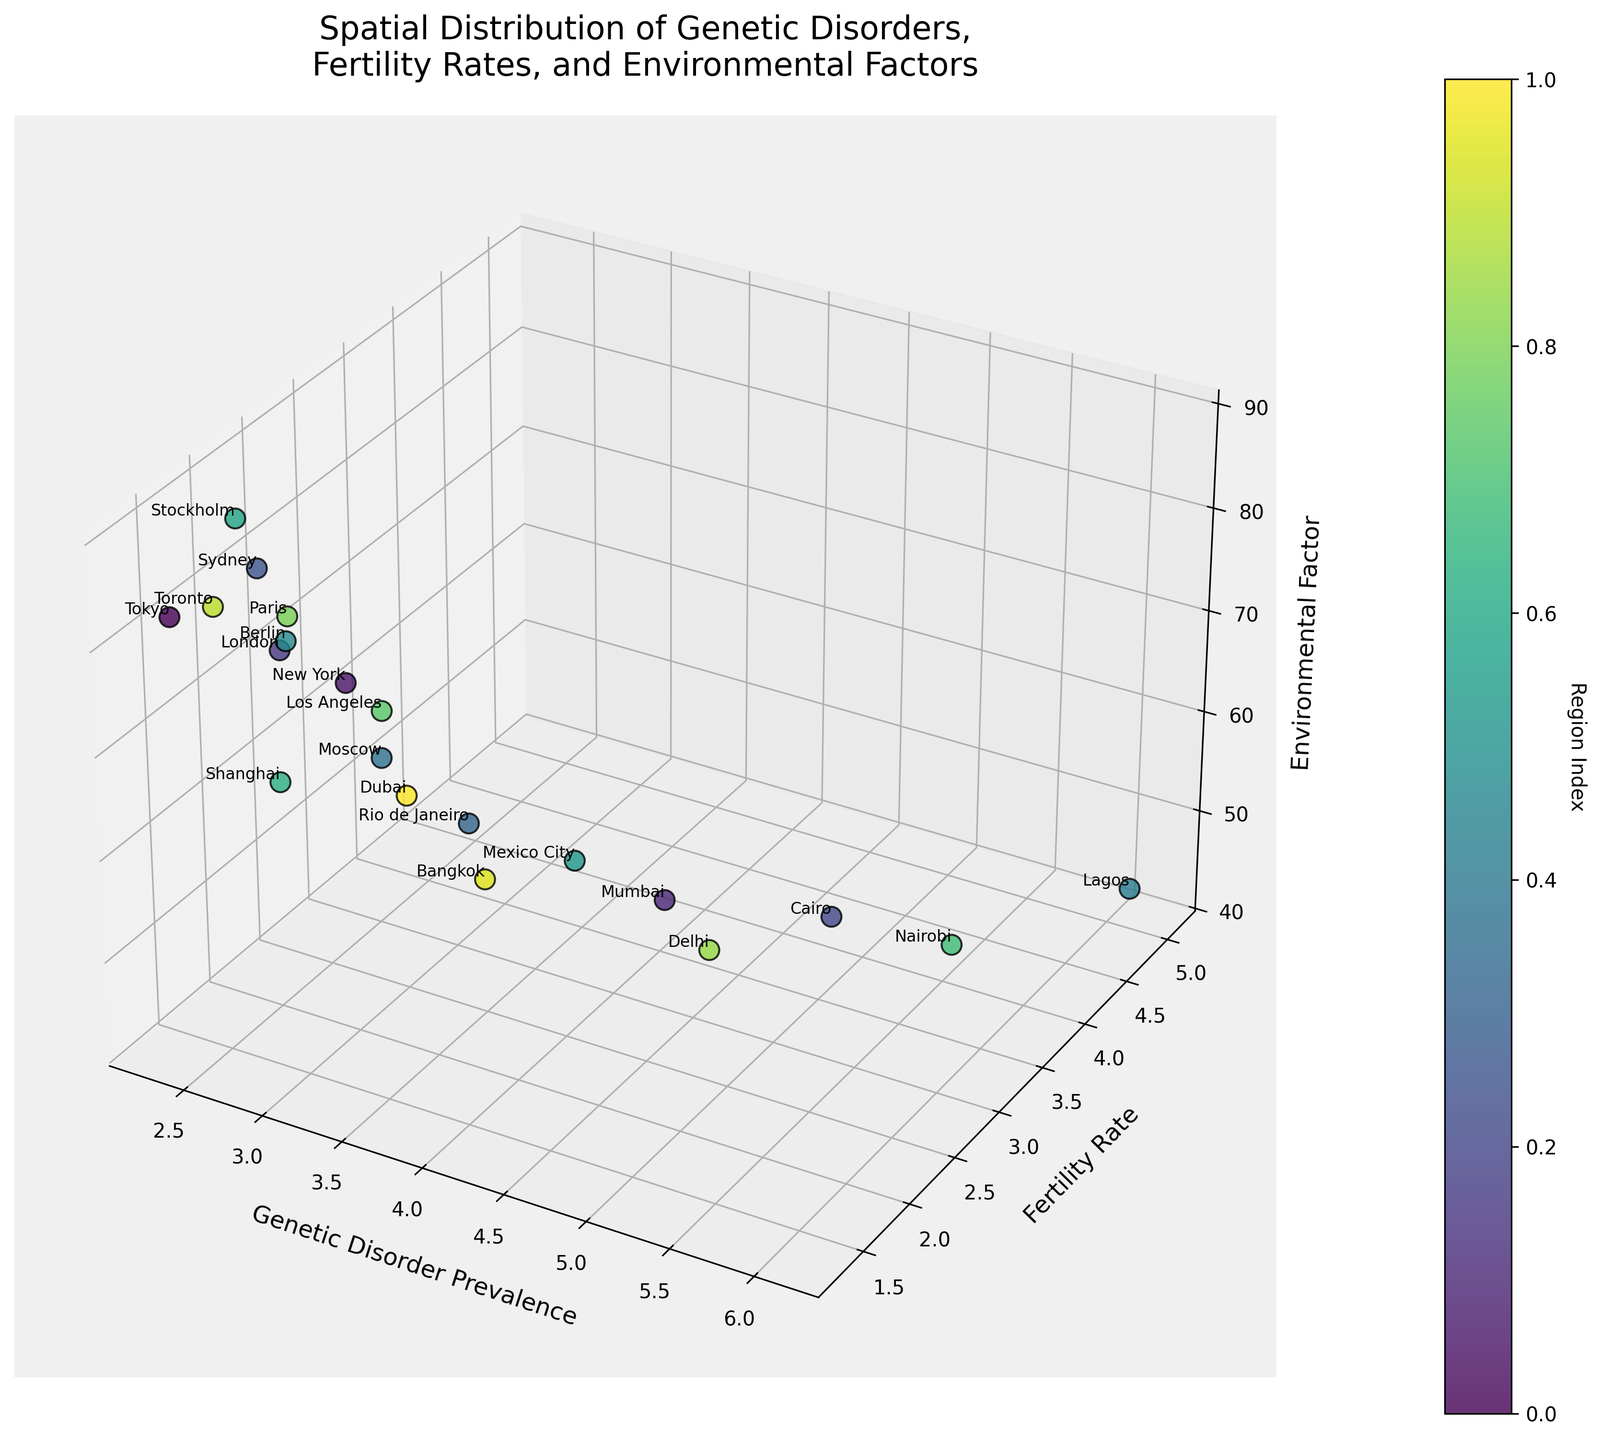What is the title of the figure? The title is displayed at the top of the figure, which reads 'Spatial Distribution of Genetic Disorders, Fertility Rates, and Environmental Factors'.
Answer: Spatial Distribution of Genetic Disorders, Fertility Rates, and Environmental Factors Which region has the highest genetic disorder prevalence? The region with the highest value on the X-axis represents the highest genetic disorder prevalence, which is Lagos at 6.1.
Answer: Lagos How many data points are displayed in the figure? Each point in the scatter plot represents a region. Counting all regions listed in the data table results in a total of 19 data points.
Answer: 19 What is the environmental factor for Nairobi, and how does it compare to the average of environmental factors? Nairobi's environmental factor is given as 49. To compare, average all environmental factors and then compare Nairobi's value to this average. The average environmental factor is (82+76+58+79+51+85+67+73+43+81+62+88+70+49+74+80+55+83+64) / 19 ≈ 70.52. Thus, Nairobi's factor (49) is below this average.
Answer: 49, below average Which region has the lowest fertility rate and what is that rate? Looking at the Y-axis for the lowest point identifies Shanghai, which has the lowest fertility rate of 1.30.
Answer: Shanghai, 1.30 Is there a correlation between fertility rate and genetic disorder prevalence based on the plotted regions? Observing the 3D plot, regions with higher genetic disorder prevalence tend to also have higher fertility rates, suggesting a positive correlation.
Answer: Positive correlation Identify two regions with similar genetic disorder prevalence but different fertility rates. New York and Moscow both have similiar genetic disorder prevalence around 3.1 and 3.5 respectively. However, New York's fertility rate is 1.79 while Moscow's is 1.50.
Answer: New York and Moscow What is the average fertility rate for regions with an environmental factor greater than 70? Regions with environmental factors greater than 70 are Tokyo, London, Sydney, Berlin, Stockholm, Toronto, and Paris. Their fertility rates are 1.36, 1.63, 1.74, 1.54, 1.85, 1.47, and 1.86 respectively. Average fertility rate = (1.36 + 1.63 + 1.74 + 1.54 + 1.85 + 1.47 + 1.86) / 7 ≈ 1.63.
Answer: Approx. 1.63 Which region is an outlier in terms of low environmental factors and high fertility rates? Lagos stands out as it has a very low environmental factor of 43 and a very high fertility rate of 5.07.
Answer: Lagos How does the environmental factor of Tokyo compare to that of Sydney and Lahore? Based on the Z-axis, Tokyo has an environmental factor of 82, Sydney 85, and Lagos (Lagos was a mistake in the question, should be Lahore, but Lahore is not in the list). Thus, Tokyo has an environmental factor close to Sydney and less than Lagos.
Answer: Close to Sydney, less than Lagos Which region has the closest values of all three variables (Genetic Disorder Prevalence, Fertility Rate, Environmental Factor) to New York? Comparing regions visually, Los Angeles has similar values to New York in genetic disorder prevalence (3.3 vs 3.1), fertility rate (1.82 vs 1.79), and environmental factor (74 vs 76).
Answer: Los Angeles 